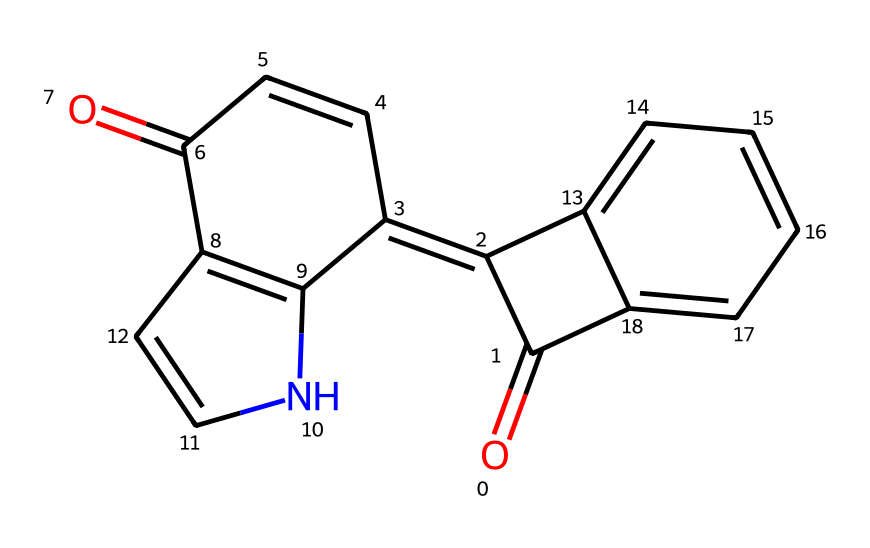What is the molecular formula of indigo dye? By analyzing the structure, we can count the number of carbon (C), hydrogen (H), oxygen (O), and nitrogen (N) atoms present. The structure contains 16 carbons, 10 hydrogens, 2 oxygens, and 1 nitrogen, leading to the molecular formula C16H10N2O2.
Answer: C16H10N2O2 How many rings are present in the indigo dye structure? Upon visual inspection of the structure, we can identify four distinct rings within the chemical structure of indigo dye. Each ring is formed by carbon atoms connected in a cyclic arrangement.
Answer: 4 Which atoms are involved in the dye's conjugated system? The presence of double bonds (C=C) indicates the involvement of carbon atoms in a conjugated system. In this structure, the conjugation extends across multiple rings and involves alternating single and double bonds, with carbon atoms primarily contributing to this feature.
Answer: Carbon atoms Is indigo dye a polar or non-polar compound? Evaluating the overall structure, including the conjugated systems and functional groups, suggests that indigo contains regions that are somewhat non-polar due to its extensive ring system, although the presence of the carbonyl groups (C=O) contributes to partial polarity. However, overall, it is considered to be mainly non-polar.
Answer: Non-polar What type of bond forms the backbone of the indigo dye structure? The backbone of the indigo dye is primarily formed by carbon-carbon (C-C) bonds in the ring structure, with additional connections involving other atoms such as nitrogen and oxygen in functional groups, but the dominant bonding is C-C.
Answer: Carbon-carbon bonds Does indigo dye contain any heteroatoms? Inspection reveals the presence of nitrogen and oxygen atoms in the structure, which are classified as heteroatoms since they differ from carbon and hydrogen, indicating that indigo is a heterocyclic compound.
Answer: Yes, nitrogen and oxygen 